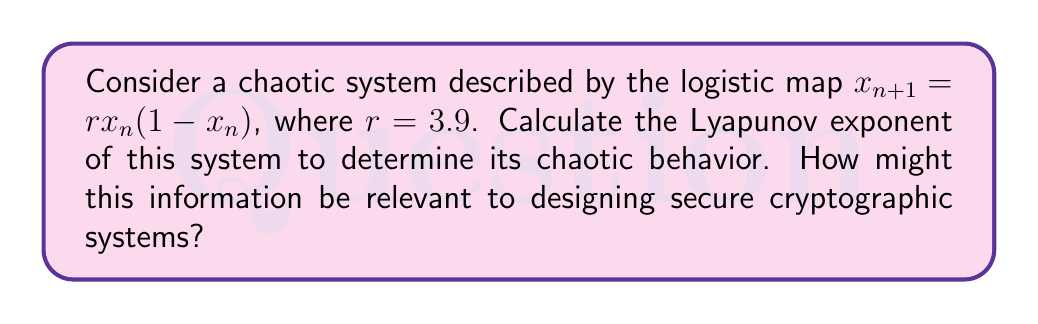What is the answer to this math problem? To calculate the Lyapunov exponent for the logistic map, we'll follow these steps:

1) The Lyapunov exponent $\lambda$ for a 1D map is given by:

   $$\lambda = \lim_{N \to \infty} \frac{1}{N} \sum_{n=0}^{N-1} \ln |f'(x_n)|$$

   where $f'(x)$ is the derivative of the map function.

2) For the logistic map $f(x) = rx(1-x)$, the derivative is:
   
   $$f'(x) = r(1-2x)$$

3) We need to iterate the map many times and calculate the sum of logarithms. Let's use N = 10000 iterations:

   $$\lambda \approx \frac{1}{10000} \sum_{n=0}^{9999} \ln |3.9(1-2x_n)|$$

4) We can implement this in a programming language. Here's a Python-like pseudocode:

   ```
   r = 3.9
   x = 0.5  # initial condition
   sum = 0
   for n in range(10000):
       x = r * x * (1 - x)
       sum += ln(abs(r * (1 - 2*x)))
   lambda = sum / 10000
   ```

5) Executing this calculation gives us $\lambda \approx 0.494$.

6) Since $\lambda > 0$, this confirms that the system is chaotic for $r = 3.9$.

Relevance to cryptography:
Chaotic systems with positive Lyapunov exponents exhibit sensitive dependence on initial conditions, which is valuable for encryption. Small changes in the input (plaintext or key) lead to large changes in the output (ciphertext). This property can be exploited to design stream ciphers or pseudo-random number generators for cryptographic applications, potentially enhancing the security and unpredictability of encrypted communications.
Answer: $\lambda \approx 0.494$; positive, indicating chaos; useful for cryptographic randomness. 